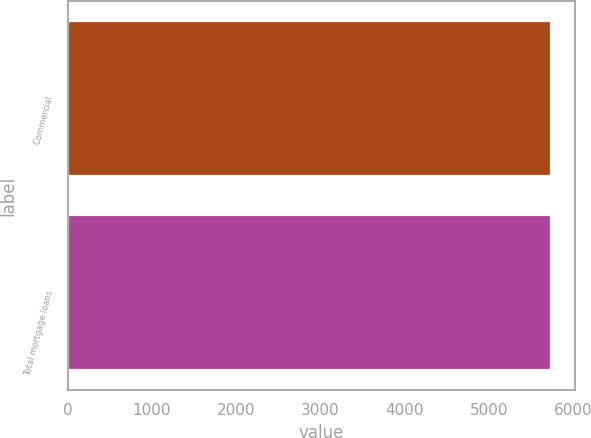Convert chart to OTSL. <chart><loc_0><loc_0><loc_500><loc_500><bar_chart><fcel>Commercial<fcel>Total mortgage loans<nl><fcel>5728<fcel>5728.1<nl></chart> 